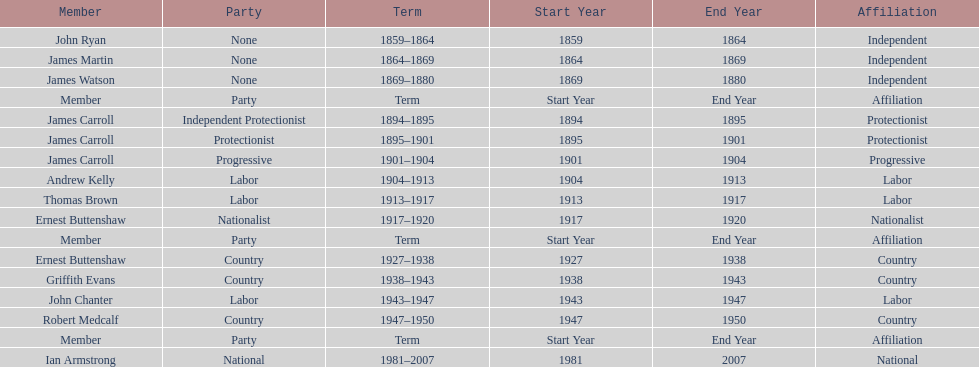How long did the fourth incarnation of the lachlan exist? 1981-2007. 